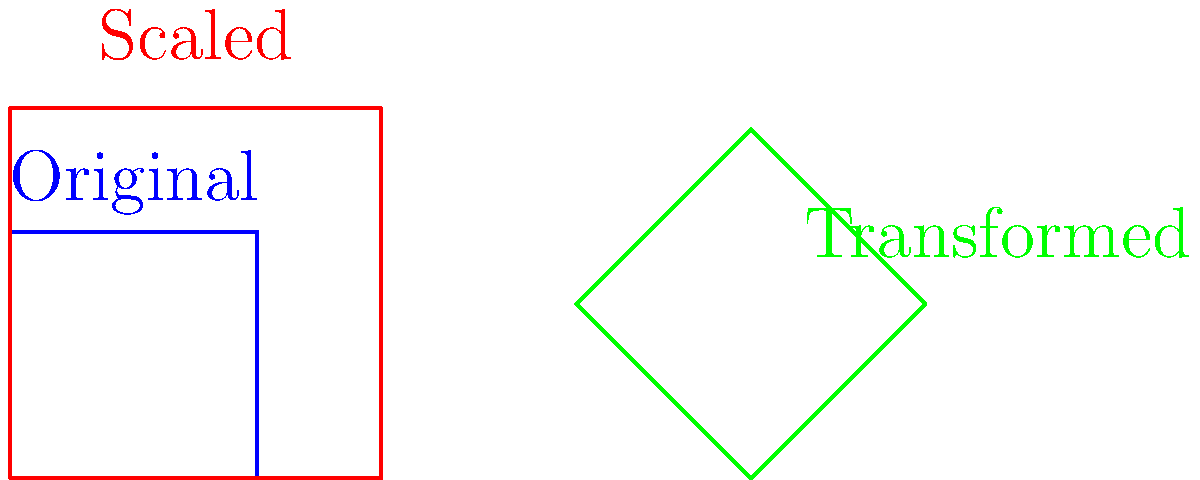A protein structure undergoes scaling and transformation to optimize immune response. The original structure is represented by a unit square. It is first scaled by a factor of 1.5, then rotated 45° and translated 3 units to the right. Calculate the area of the final transformed protein structure. Let's approach this step-by-step:

1) The original protein structure is a unit square, so its initial area is:
   $$A_1 = 1 \times 1 = 1 \text{ square unit}$$

2) The structure is scaled by a factor of 1.5. This affects the area as follows:
   $$A_2 = (1.5)^2 \times A_1 = 2.25 \text{ square units}$$

3) The rotation of 45° doesn't change the area of the structure.

4) The translation of 3 units to the right also doesn't affect the area.

Therefore, the final area of the transformed protein structure remains 2.25 square units.

This transformation could potentially optimize immune response by increasing the surface area of the protein, allowing for more binding sites or improved interaction with immune cells.
Answer: 2.25 square units 